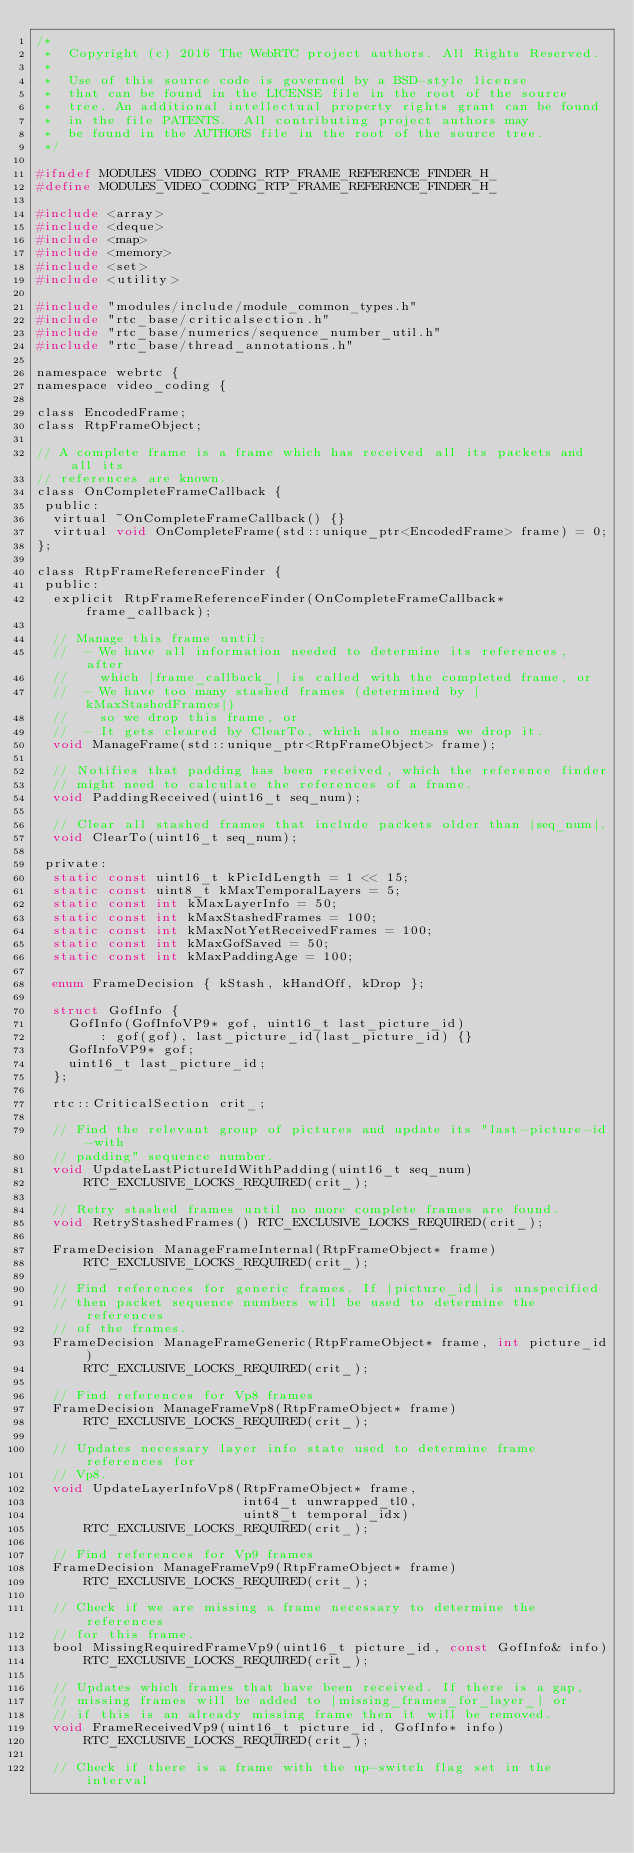<code> <loc_0><loc_0><loc_500><loc_500><_C_>/*
 *  Copyright (c) 2016 The WebRTC project authors. All Rights Reserved.
 *
 *  Use of this source code is governed by a BSD-style license
 *  that can be found in the LICENSE file in the root of the source
 *  tree. An additional intellectual property rights grant can be found
 *  in the file PATENTS.  All contributing project authors may
 *  be found in the AUTHORS file in the root of the source tree.
 */

#ifndef MODULES_VIDEO_CODING_RTP_FRAME_REFERENCE_FINDER_H_
#define MODULES_VIDEO_CODING_RTP_FRAME_REFERENCE_FINDER_H_

#include <array>
#include <deque>
#include <map>
#include <memory>
#include <set>
#include <utility>

#include "modules/include/module_common_types.h"
#include "rtc_base/criticalsection.h"
#include "rtc_base/numerics/sequence_number_util.h"
#include "rtc_base/thread_annotations.h"

namespace webrtc {
namespace video_coding {

class EncodedFrame;
class RtpFrameObject;

// A complete frame is a frame which has received all its packets and all its
// references are known.
class OnCompleteFrameCallback {
 public:
  virtual ~OnCompleteFrameCallback() {}
  virtual void OnCompleteFrame(std::unique_ptr<EncodedFrame> frame) = 0;
};

class RtpFrameReferenceFinder {
 public:
  explicit RtpFrameReferenceFinder(OnCompleteFrameCallback* frame_callback);

  // Manage this frame until:
  //  - We have all information needed to determine its references, after
  //    which |frame_callback_| is called with the completed frame, or
  //  - We have too many stashed frames (determined by |kMaxStashedFrames|)
  //    so we drop this frame, or
  //  - It gets cleared by ClearTo, which also means we drop it.
  void ManageFrame(std::unique_ptr<RtpFrameObject> frame);

  // Notifies that padding has been received, which the reference finder
  // might need to calculate the references of a frame.
  void PaddingReceived(uint16_t seq_num);

  // Clear all stashed frames that include packets older than |seq_num|.
  void ClearTo(uint16_t seq_num);

 private:
  static const uint16_t kPicIdLength = 1 << 15;
  static const uint8_t kMaxTemporalLayers = 5;
  static const int kMaxLayerInfo = 50;
  static const int kMaxStashedFrames = 100;
  static const int kMaxNotYetReceivedFrames = 100;
  static const int kMaxGofSaved = 50;
  static const int kMaxPaddingAge = 100;

  enum FrameDecision { kStash, kHandOff, kDrop };

  struct GofInfo {
    GofInfo(GofInfoVP9* gof, uint16_t last_picture_id)
        : gof(gof), last_picture_id(last_picture_id) {}
    GofInfoVP9* gof;
    uint16_t last_picture_id;
  };

  rtc::CriticalSection crit_;

  // Find the relevant group of pictures and update its "last-picture-id-with
  // padding" sequence number.
  void UpdateLastPictureIdWithPadding(uint16_t seq_num)
      RTC_EXCLUSIVE_LOCKS_REQUIRED(crit_);

  // Retry stashed frames until no more complete frames are found.
  void RetryStashedFrames() RTC_EXCLUSIVE_LOCKS_REQUIRED(crit_);

  FrameDecision ManageFrameInternal(RtpFrameObject* frame)
      RTC_EXCLUSIVE_LOCKS_REQUIRED(crit_);

  // Find references for generic frames. If |picture_id| is unspecified
  // then packet sequence numbers will be used to determine the references
  // of the frames.
  FrameDecision ManageFrameGeneric(RtpFrameObject* frame, int picture_id)
      RTC_EXCLUSIVE_LOCKS_REQUIRED(crit_);

  // Find references for Vp8 frames
  FrameDecision ManageFrameVp8(RtpFrameObject* frame)
      RTC_EXCLUSIVE_LOCKS_REQUIRED(crit_);

  // Updates necessary layer info state used to determine frame references for
  // Vp8.
  void UpdateLayerInfoVp8(RtpFrameObject* frame,
                          int64_t unwrapped_tl0,
                          uint8_t temporal_idx)
      RTC_EXCLUSIVE_LOCKS_REQUIRED(crit_);

  // Find references for Vp9 frames
  FrameDecision ManageFrameVp9(RtpFrameObject* frame)
      RTC_EXCLUSIVE_LOCKS_REQUIRED(crit_);

  // Check if we are missing a frame necessary to determine the references
  // for this frame.
  bool MissingRequiredFrameVp9(uint16_t picture_id, const GofInfo& info)
      RTC_EXCLUSIVE_LOCKS_REQUIRED(crit_);

  // Updates which frames that have been received. If there is a gap,
  // missing frames will be added to |missing_frames_for_layer_| or
  // if this is an already missing frame then it will be removed.
  void FrameReceivedVp9(uint16_t picture_id, GofInfo* info)
      RTC_EXCLUSIVE_LOCKS_REQUIRED(crit_);

  // Check if there is a frame with the up-switch flag set in the interval</code> 